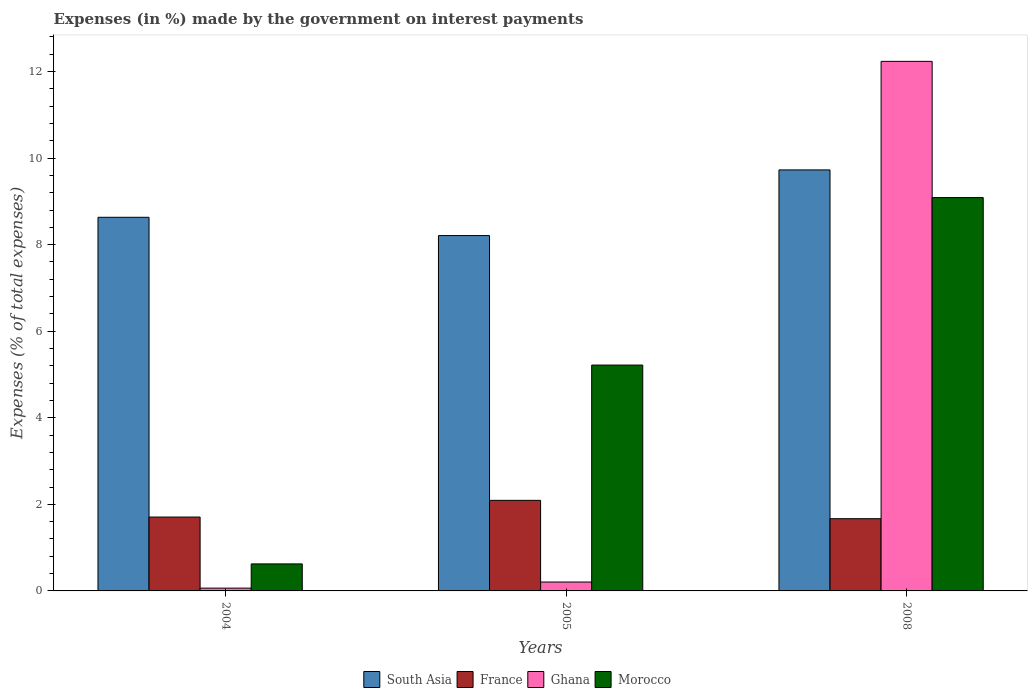How many different coloured bars are there?
Your answer should be very brief. 4. Are the number of bars per tick equal to the number of legend labels?
Offer a terse response. Yes. Are the number of bars on each tick of the X-axis equal?
Your response must be concise. Yes. How many bars are there on the 2nd tick from the left?
Give a very brief answer. 4. In how many cases, is the number of bars for a given year not equal to the number of legend labels?
Your answer should be very brief. 0. What is the percentage of expenses made by the government on interest payments in Morocco in 2004?
Keep it short and to the point. 0.62. Across all years, what is the maximum percentage of expenses made by the government on interest payments in Ghana?
Your answer should be very brief. 12.23. Across all years, what is the minimum percentage of expenses made by the government on interest payments in South Asia?
Ensure brevity in your answer.  8.21. In which year was the percentage of expenses made by the government on interest payments in Ghana maximum?
Your response must be concise. 2008. In which year was the percentage of expenses made by the government on interest payments in France minimum?
Keep it short and to the point. 2008. What is the total percentage of expenses made by the government on interest payments in France in the graph?
Offer a terse response. 5.47. What is the difference between the percentage of expenses made by the government on interest payments in South Asia in 2005 and that in 2008?
Provide a succinct answer. -1.52. What is the difference between the percentage of expenses made by the government on interest payments in France in 2008 and the percentage of expenses made by the government on interest payments in Ghana in 2004?
Keep it short and to the point. 1.6. What is the average percentage of expenses made by the government on interest payments in South Asia per year?
Offer a very short reply. 8.86. In the year 2004, what is the difference between the percentage of expenses made by the government on interest payments in Morocco and percentage of expenses made by the government on interest payments in France?
Provide a succinct answer. -1.08. What is the ratio of the percentage of expenses made by the government on interest payments in Ghana in 2004 to that in 2005?
Ensure brevity in your answer.  0.31. What is the difference between the highest and the second highest percentage of expenses made by the government on interest payments in Ghana?
Provide a succinct answer. 12.03. What is the difference between the highest and the lowest percentage of expenses made by the government on interest payments in Morocco?
Make the answer very short. 8.46. In how many years, is the percentage of expenses made by the government on interest payments in France greater than the average percentage of expenses made by the government on interest payments in France taken over all years?
Give a very brief answer. 1. What does the 3rd bar from the right in 2005 represents?
Give a very brief answer. France. Is it the case that in every year, the sum of the percentage of expenses made by the government on interest payments in France and percentage of expenses made by the government on interest payments in Ghana is greater than the percentage of expenses made by the government on interest payments in Morocco?
Make the answer very short. No. How many years are there in the graph?
Provide a short and direct response. 3. What is the difference between two consecutive major ticks on the Y-axis?
Your response must be concise. 2. How are the legend labels stacked?
Your answer should be very brief. Horizontal. What is the title of the graph?
Ensure brevity in your answer.  Expenses (in %) made by the government on interest payments. Does "Solomon Islands" appear as one of the legend labels in the graph?
Your answer should be compact. No. What is the label or title of the X-axis?
Make the answer very short. Years. What is the label or title of the Y-axis?
Your answer should be compact. Expenses (% of total expenses). What is the Expenses (% of total expenses) of South Asia in 2004?
Your answer should be very brief. 8.63. What is the Expenses (% of total expenses) of France in 2004?
Offer a terse response. 1.71. What is the Expenses (% of total expenses) in Ghana in 2004?
Your answer should be compact. 0.06. What is the Expenses (% of total expenses) of Morocco in 2004?
Keep it short and to the point. 0.62. What is the Expenses (% of total expenses) in South Asia in 2005?
Your answer should be compact. 8.21. What is the Expenses (% of total expenses) of France in 2005?
Offer a terse response. 2.09. What is the Expenses (% of total expenses) in Ghana in 2005?
Your answer should be very brief. 0.21. What is the Expenses (% of total expenses) in Morocco in 2005?
Give a very brief answer. 5.22. What is the Expenses (% of total expenses) of South Asia in 2008?
Make the answer very short. 9.73. What is the Expenses (% of total expenses) of France in 2008?
Provide a succinct answer. 1.67. What is the Expenses (% of total expenses) in Ghana in 2008?
Your response must be concise. 12.23. What is the Expenses (% of total expenses) of Morocco in 2008?
Make the answer very short. 9.09. Across all years, what is the maximum Expenses (% of total expenses) of South Asia?
Make the answer very short. 9.73. Across all years, what is the maximum Expenses (% of total expenses) of France?
Your answer should be compact. 2.09. Across all years, what is the maximum Expenses (% of total expenses) in Ghana?
Your answer should be very brief. 12.23. Across all years, what is the maximum Expenses (% of total expenses) of Morocco?
Offer a very short reply. 9.09. Across all years, what is the minimum Expenses (% of total expenses) of South Asia?
Your response must be concise. 8.21. Across all years, what is the minimum Expenses (% of total expenses) of France?
Offer a very short reply. 1.67. Across all years, what is the minimum Expenses (% of total expenses) in Ghana?
Your response must be concise. 0.06. Across all years, what is the minimum Expenses (% of total expenses) in Morocco?
Make the answer very short. 0.62. What is the total Expenses (% of total expenses) in South Asia in the graph?
Provide a short and direct response. 26.57. What is the total Expenses (% of total expenses) of France in the graph?
Make the answer very short. 5.47. What is the total Expenses (% of total expenses) of Ghana in the graph?
Provide a short and direct response. 12.5. What is the total Expenses (% of total expenses) in Morocco in the graph?
Your answer should be very brief. 14.93. What is the difference between the Expenses (% of total expenses) in South Asia in 2004 and that in 2005?
Your answer should be very brief. 0.42. What is the difference between the Expenses (% of total expenses) of France in 2004 and that in 2005?
Ensure brevity in your answer.  -0.39. What is the difference between the Expenses (% of total expenses) in Ghana in 2004 and that in 2005?
Make the answer very short. -0.14. What is the difference between the Expenses (% of total expenses) of Morocco in 2004 and that in 2005?
Give a very brief answer. -4.59. What is the difference between the Expenses (% of total expenses) of South Asia in 2004 and that in 2008?
Your answer should be compact. -1.09. What is the difference between the Expenses (% of total expenses) in France in 2004 and that in 2008?
Provide a succinct answer. 0.04. What is the difference between the Expenses (% of total expenses) of Ghana in 2004 and that in 2008?
Your answer should be compact. -12.17. What is the difference between the Expenses (% of total expenses) of Morocco in 2004 and that in 2008?
Keep it short and to the point. -8.46. What is the difference between the Expenses (% of total expenses) of South Asia in 2005 and that in 2008?
Keep it short and to the point. -1.52. What is the difference between the Expenses (% of total expenses) of France in 2005 and that in 2008?
Keep it short and to the point. 0.42. What is the difference between the Expenses (% of total expenses) in Ghana in 2005 and that in 2008?
Offer a terse response. -12.03. What is the difference between the Expenses (% of total expenses) of Morocco in 2005 and that in 2008?
Your answer should be compact. -3.87. What is the difference between the Expenses (% of total expenses) of South Asia in 2004 and the Expenses (% of total expenses) of France in 2005?
Make the answer very short. 6.54. What is the difference between the Expenses (% of total expenses) of South Asia in 2004 and the Expenses (% of total expenses) of Ghana in 2005?
Ensure brevity in your answer.  8.43. What is the difference between the Expenses (% of total expenses) of South Asia in 2004 and the Expenses (% of total expenses) of Morocco in 2005?
Your answer should be compact. 3.41. What is the difference between the Expenses (% of total expenses) in France in 2004 and the Expenses (% of total expenses) in Ghana in 2005?
Your answer should be very brief. 1.5. What is the difference between the Expenses (% of total expenses) in France in 2004 and the Expenses (% of total expenses) in Morocco in 2005?
Ensure brevity in your answer.  -3.51. What is the difference between the Expenses (% of total expenses) of Ghana in 2004 and the Expenses (% of total expenses) of Morocco in 2005?
Keep it short and to the point. -5.15. What is the difference between the Expenses (% of total expenses) in South Asia in 2004 and the Expenses (% of total expenses) in France in 2008?
Offer a very short reply. 6.96. What is the difference between the Expenses (% of total expenses) in South Asia in 2004 and the Expenses (% of total expenses) in Ghana in 2008?
Ensure brevity in your answer.  -3.6. What is the difference between the Expenses (% of total expenses) of South Asia in 2004 and the Expenses (% of total expenses) of Morocco in 2008?
Ensure brevity in your answer.  -0.46. What is the difference between the Expenses (% of total expenses) in France in 2004 and the Expenses (% of total expenses) in Ghana in 2008?
Make the answer very short. -10.53. What is the difference between the Expenses (% of total expenses) in France in 2004 and the Expenses (% of total expenses) in Morocco in 2008?
Offer a terse response. -7.38. What is the difference between the Expenses (% of total expenses) in Ghana in 2004 and the Expenses (% of total expenses) in Morocco in 2008?
Ensure brevity in your answer.  -9.02. What is the difference between the Expenses (% of total expenses) in South Asia in 2005 and the Expenses (% of total expenses) in France in 2008?
Make the answer very short. 6.54. What is the difference between the Expenses (% of total expenses) of South Asia in 2005 and the Expenses (% of total expenses) of Ghana in 2008?
Make the answer very short. -4.03. What is the difference between the Expenses (% of total expenses) in South Asia in 2005 and the Expenses (% of total expenses) in Morocco in 2008?
Keep it short and to the point. -0.88. What is the difference between the Expenses (% of total expenses) of France in 2005 and the Expenses (% of total expenses) of Ghana in 2008?
Offer a terse response. -10.14. What is the difference between the Expenses (% of total expenses) of France in 2005 and the Expenses (% of total expenses) of Morocco in 2008?
Give a very brief answer. -7. What is the difference between the Expenses (% of total expenses) of Ghana in 2005 and the Expenses (% of total expenses) of Morocco in 2008?
Offer a terse response. -8.88. What is the average Expenses (% of total expenses) of South Asia per year?
Offer a terse response. 8.86. What is the average Expenses (% of total expenses) in France per year?
Your answer should be compact. 1.82. What is the average Expenses (% of total expenses) of Ghana per year?
Your response must be concise. 4.17. What is the average Expenses (% of total expenses) of Morocco per year?
Your response must be concise. 4.98. In the year 2004, what is the difference between the Expenses (% of total expenses) in South Asia and Expenses (% of total expenses) in France?
Give a very brief answer. 6.93. In the year 2004, what is the difference between the Expenses (% of total expenses) in South Asia and Expenses (% of total expenses) in Ghana?
Offer a terse response. 8.57. In the year 2004, what is the difference between the Expenses (% of total expenses) of South Asia and Expenses (% of total expenses) of Morocco?
Ensure brevity in your answer.  8.01. In the year 2004, what is the difference between the Expenses (% of total expenses) of France and Expenses (% of total expenses) of Ghana?
Your response must be concise. 1.64. In the year 2004, what is the difference between the Expenses (% of total expenses) in France and Expenses (% of total expenses) in Morocco?
Your answer should be very brief. 1.08. In the year 2004, what is the difference between the Expenses (% of total expenses) in Ghana and Expenses (% of total expenses) in Morocco?
Give a very brief answer. -0.56. In the year 2005, what is the difference between the Expenses (% of total expenses) in South Asia and Expenses (% of total expenses) in France?
Keep it short and to the point. 6.12. In the year 2005, what is the difference between the Expenses (% of total expenses) of South Asia and Expenses (% of total expenses) of Ghana?
Provide a succinct answer. 8. In the year 2005, what is the difference between the Expenses (% of total expenses) of South Asia and Expenses (% of total expenses) of Morocco?
Your answer should be very brief. 2.99. In the year 2005, what is the difference between the Expenses (% of total expenses) in France and Expenses (% of total expenses) in Ghana?
Keep it short and to the point. 1.89. In the year 2005, what is the difference between the Expenses (% of total expenses) in France and Expenses (% of total expenses) in Morocco?
Your response must be concise. -3.13. In the year 2005, what is the difference between the Expenses (% of total expenses) in Ghana and Expenses (% of total expenses) in Morocco?
Your answer should be very brief. -5.01. In the year 2008, what is the difference between the Expenses (% of total expenses) in South Asia and Expenses (% of total expenses) in France?
Offer a very short reply. 8.06. In the year 2008, what is the difference between the Expenses (% of total expenses) in South Asia and Expenses (% of total expenses) in Ghana?
Your answer should be very brief. -2.51. In the year 2008, what is the difference between the Expenses (% of total expenses) of South Asia and Expenses (% of total expenses) of Morocco?
Offer a terse response. 0.64. In the year 2008, what is the difference between the Expenses (% of total expenses) in France and Expenses (% of total expenses) in Ghana?
Provide a succinct answer. -10.57. In the year 2008, what is the difference between the Expenses (% of total expenses) in France and Expenses (% of total expenses) in Morocco?
Your answer should be very brief. -7.42. In the year 2008, what is the difference between the Expenses (% of total expenses) in Ghana and Expenses (% of total expenses) in Morocco?
Make the answer very short. 3.15. What is the ratio of the Expenses (% of total expenses) in South Asia in 2004 to that in 2005?
Give a very brief answer. 1.05. What is the ratio of the Expenses (% of total expenses) in France in 2004 to that in 2005?
Your answer should be compact. 0.82. What is the ratio of the Expenses (% of total expenses) in Ghana in 2004 to that in 2005?
Ensure brevity in your answer.  0.31. What is the ratio of the Expenses (% of total expenses) of Morocco in 2004 to that in 2005?
Your answer should be compact. 0.12. What is the ratio of the Expenses (% of total expenses) of South Asia in 2004 to that in 2008?
Your response must be concise. 0.89. What is the ratio of the Expenses (% of total expenses) in France in 2004 to that in 2008?
Your answer should be compact. 1.02. What is the ratio of the Expenses (% of total expenses) in Ghana in 2004 to that in 2008?
Keep it short and to the point. 0.01. What is the ratio of the Expenses (% of total expenses) in Morocco in 2004 to that in 2008?
Offer a very short reply. 0.07. What is the ratio of the Expenses (% of total expenses) in South Asia in 2005 to that in 2008?
Your answer should be very brief. 0.84. What is the ratio of the Expenses (% of total expenses) in France in 2005 to that in 2008?
Your response must be concise. 1.25. What is the ratio of the Expenses (% of total expenses) in Ghana in 2005 to that in 2008?
Provide a short and direct response. 0.02. What is the ratio of the Expenses (% of total expenses) of Morocco in 2005 to that in 2008?
Keep it short and to the point. 0.57. What is the difference between the highest and the second highest Expenses (% of total expenses) of South Asia?
Make the answer very short. 1.09. What is the difference between the highest and the second highest Expenses (% of total expenses) in France?
Offer a terse response. 0.39. What is the difference between the highest and the second highest Expenses (% of total expenses) of Ghana?
Make the answer very short. 12.03. What is the difference between the highest and the second highest Expenses (% of total expenses) of Morocco?
Give a very brief answer. 3.87. What is the difference between the highest and the lowest Expenses (% of total expenses) of South Asia?
Provide a short and direct response. 1.52. What is the difference between the highest and the lowest Expenses (% of total expenses) of France?
Make the answer very short. 0.42. What is the difference between the highest and the lowest Expenses (% of total expenses) of Ghana?
Provide a succinct answer. 12.17. What is the difference between the highest and the lowest Expenses (% of total expenses) in Morocco?
Keep it short and to the point. 8.46. 